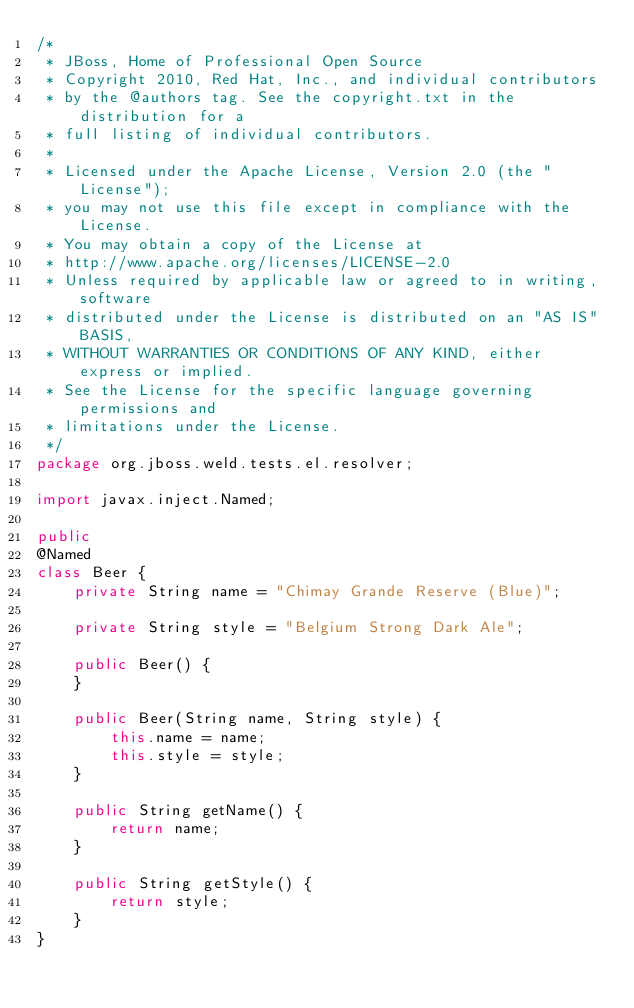Convert code to text. <code><loc_0><loc_0><loc_500><loc_500><_Java_>/*
 * JBoss, Home of Professional Open Source
 * Copyright 2010, Red Hat, Inc., and individual contributors
 * by the @authors tag. See the copyright.txt in the distribution for a
 * full listing of individual contributors.
 *
 * Licensed under the Apache License, Version 2.0 (the "License");
 * you may not use this file except in compliance with the License.
 * You may obtain a copy of the License at
 * http://www.apache.org/licenses/LICENSE-2.0
 * Unless required by applicable law or agreed to in writing, software
 * distributed under the License is distributed on an "AS IS" BASIS,
 * WITHOUT WARRANTIES OR CONDITIONS OF ANY KIND, either express or implied.
 * See the License for the specific language governing permissions and
 * limitations under the License.
 */
package org.jboss.weld.tests.el.resolver;

import javax.inject.Named;

public
@Named
class Beer {
    private String name = "Chimay Grande Reserve (Blue)";

    private String style = "Belgium Strong Dark Ale";

    public Beer() {
    }

    public Beer(String name, String style) {
        this.name = name;
        this.style = style;
    }

    public String getName() {
        return name;
    }

    public String getStyle() {
        return style;
    }
}
</code> 